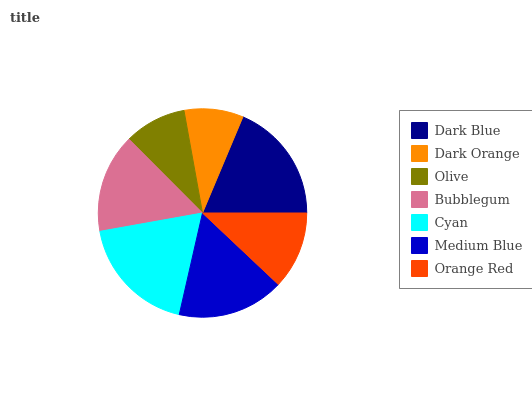Is Dark Orange the minimum?
Answer yes or no. Yes. Is Dark Blue the maximum?
Answer yes or no. Yes. Is Olive the minimum?
Answer yes or no. No. Is Olive the maximum?
Answer yes or no. No. Is Olive greater than Dark Orange?
Answer yes or no. Yes. Is Dark Orange less than Olive?
Answer yes or no. Yes. Is Dark Orange greater than Olive?
Answer yes or no. No. Is Olive less than Dark Orange?
Answer yes or no. No. Is Bubblegum the high median?
Answer yes or no. Yes. Is Bubblegum the low median?
Answer yes or no. Yes. Is Orange Red the high median?
Answer yes or no. No. Is Olive the low median?
Answer yes or no. No. 